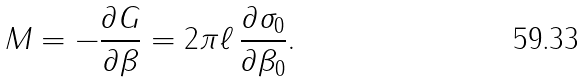Convert formula to latex. <formula><loc_0><loc_0><loc_500><loc_500>M = - \frac { \partial G } { \partial \beta } = 2 \pi \ell \, \frac { \partial \sigma _ { 0 } } { \partial \beta _ { 0 } } .</formula> 